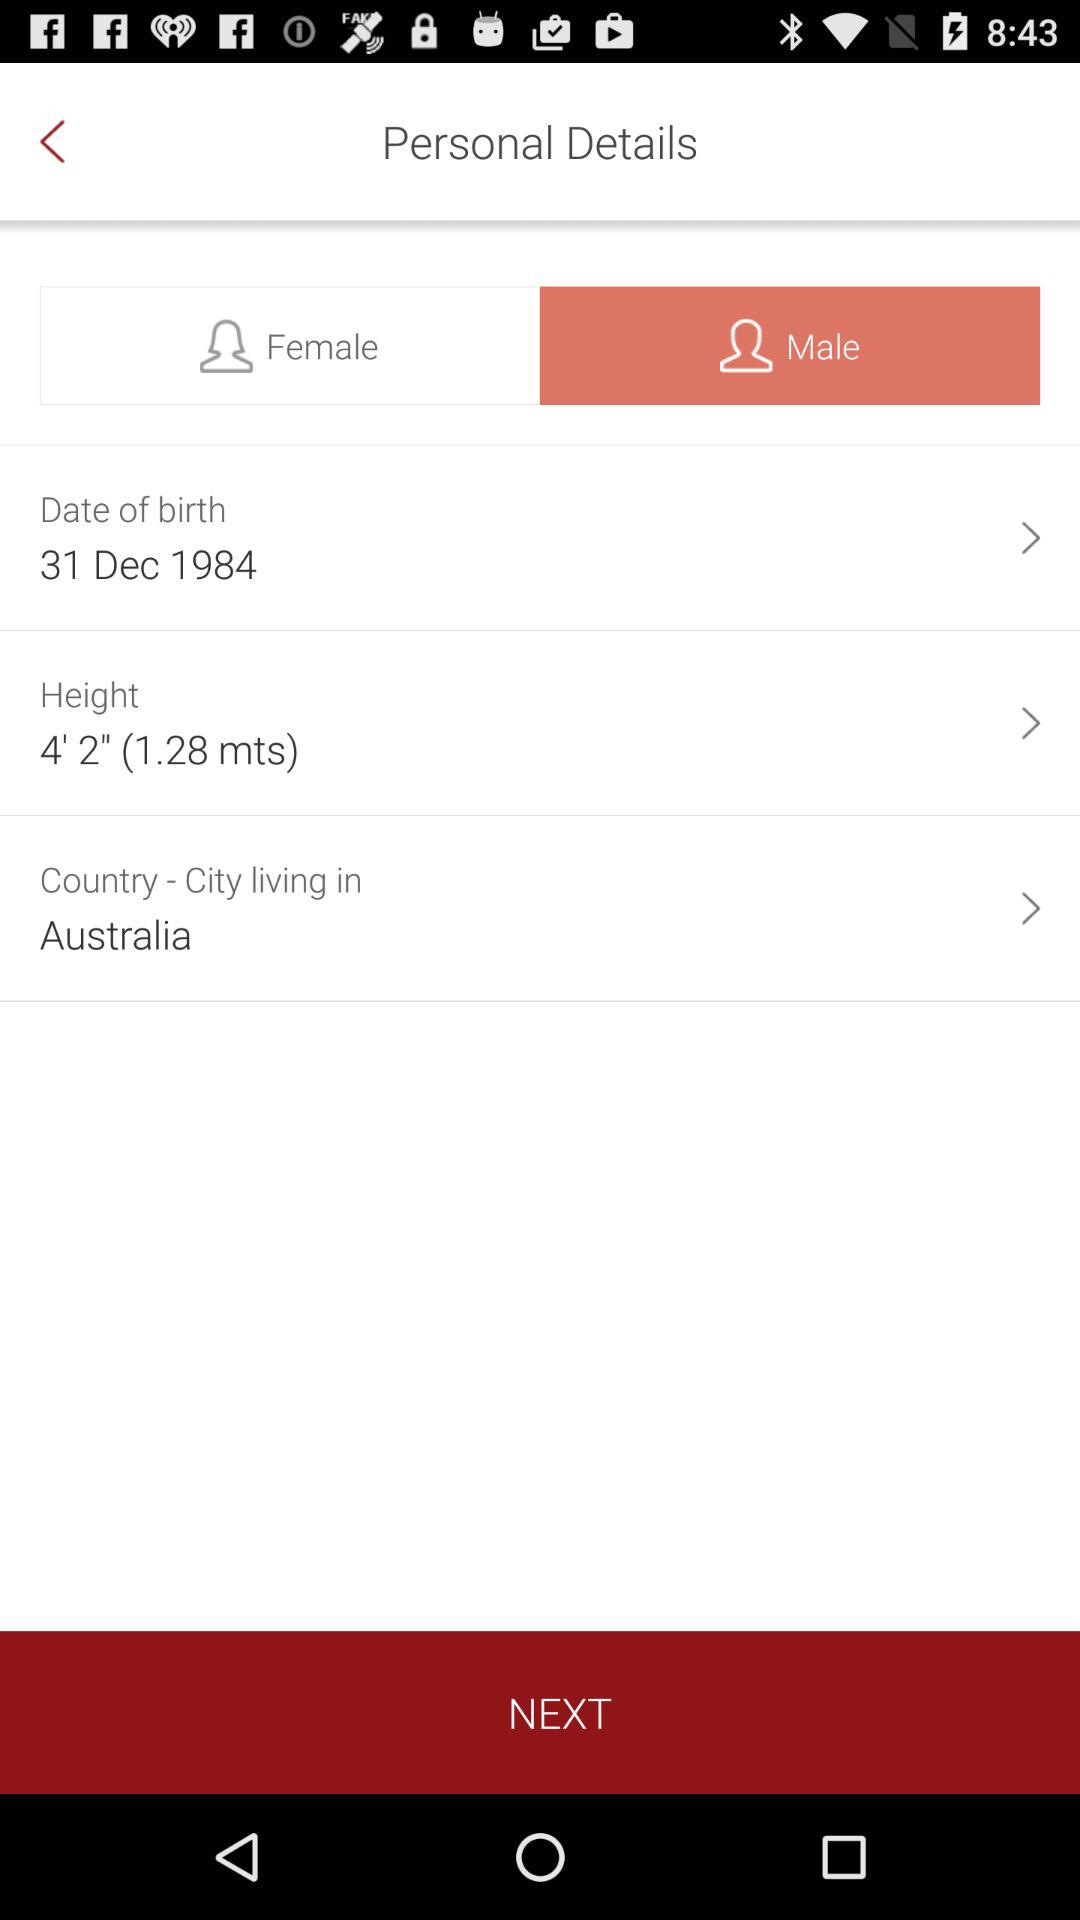What is the country name? The country's name is "Australia". 